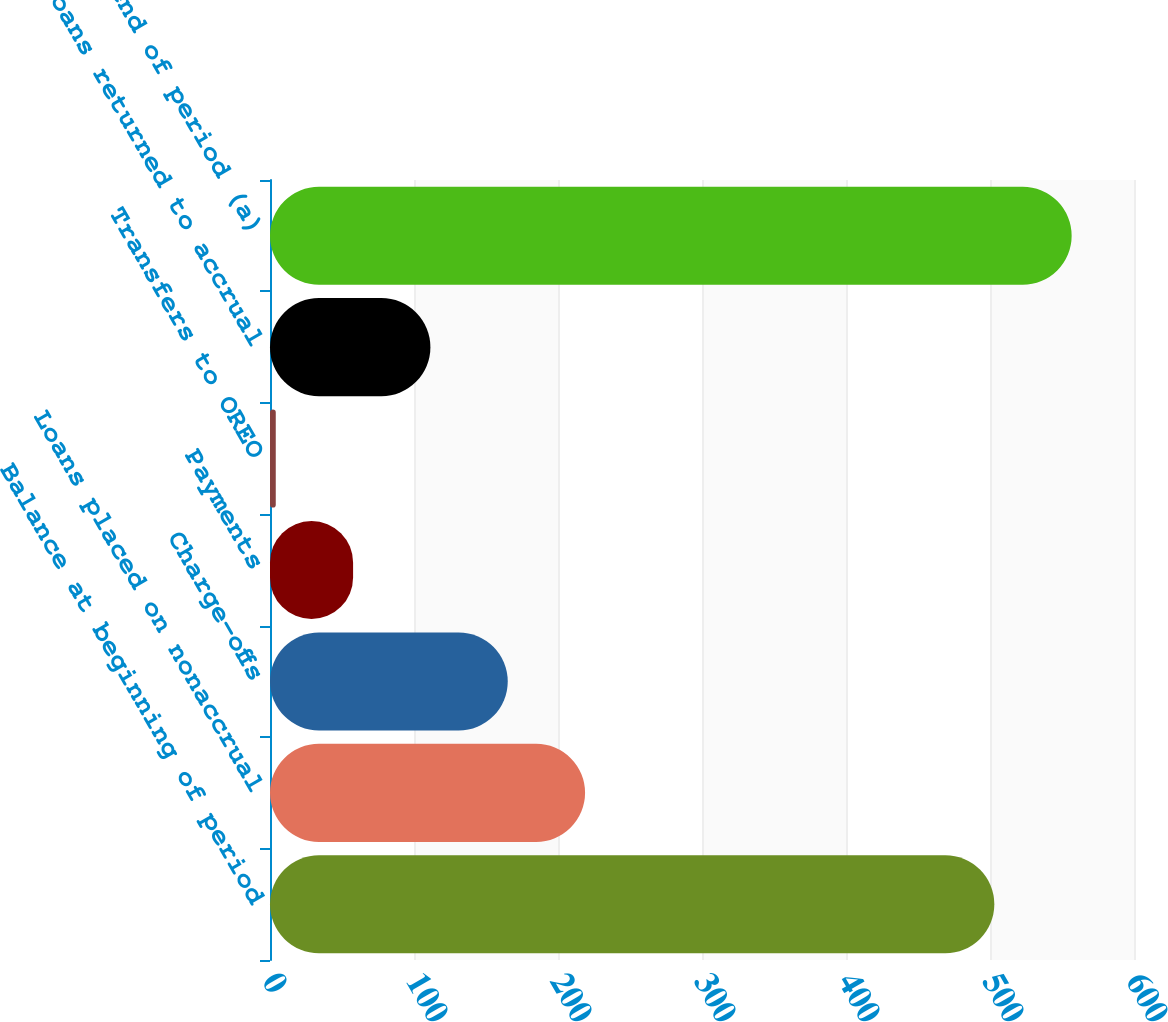<chart> <loc_0><loc_0><loc_500><loc_500><bar_chart><fcel>Balance at beginning of period<fcel>Loans placed on nonaccrual<fcel>Charge-offs<fcel>Payments<fcel>Transfers to OREO<fcel>Loans returned to accrual<fcel>Balance at end of period (a)<nl><fcel>503<fcel>218.8<fcel>165.1<fcel>57.7<fcel>4<fcel>111.4<fcel>556.7<nl></chart> 